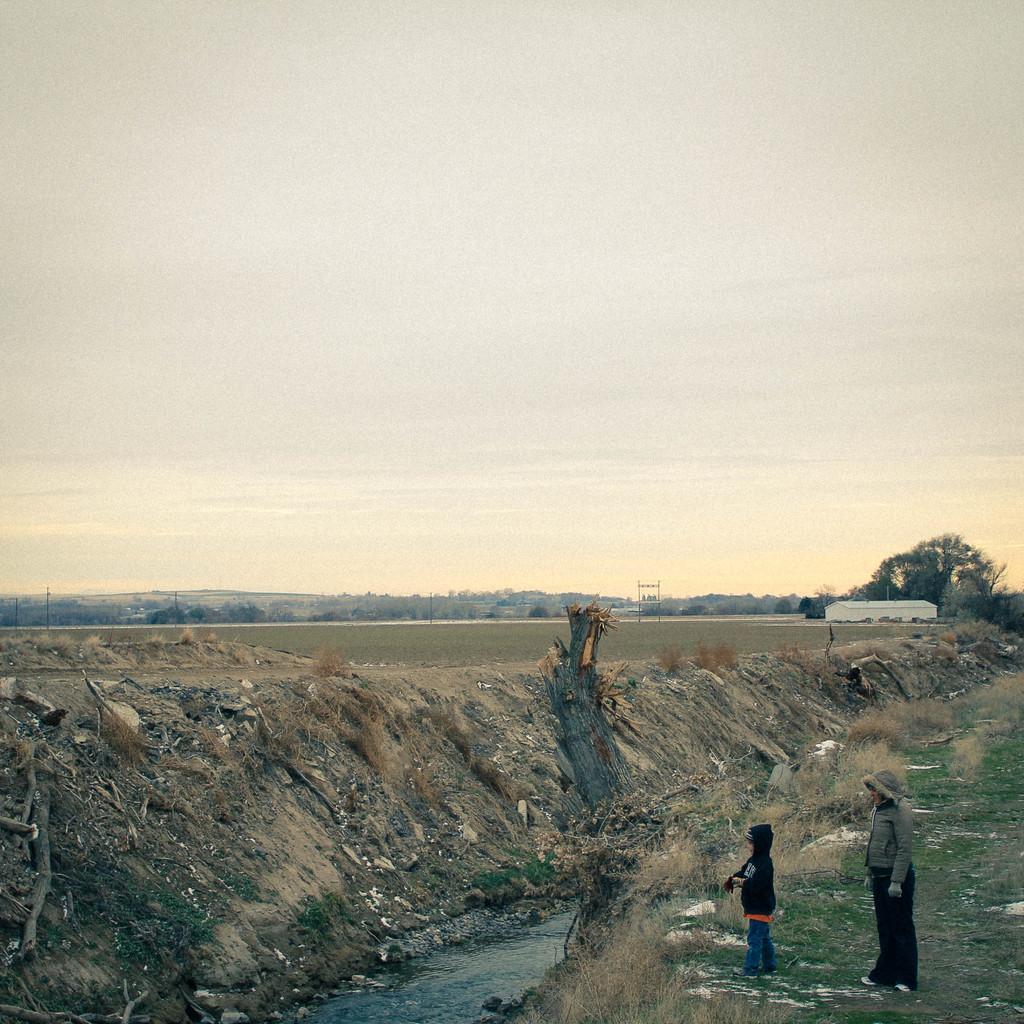Could you give a brief overview of what you see in this image? In this image I can see two persons standing. The person at right wearing gray shirt, black pant and the person at left wearing black shirt, blue pant. I can also see water, background I can see trees in green color and sky in white color. 